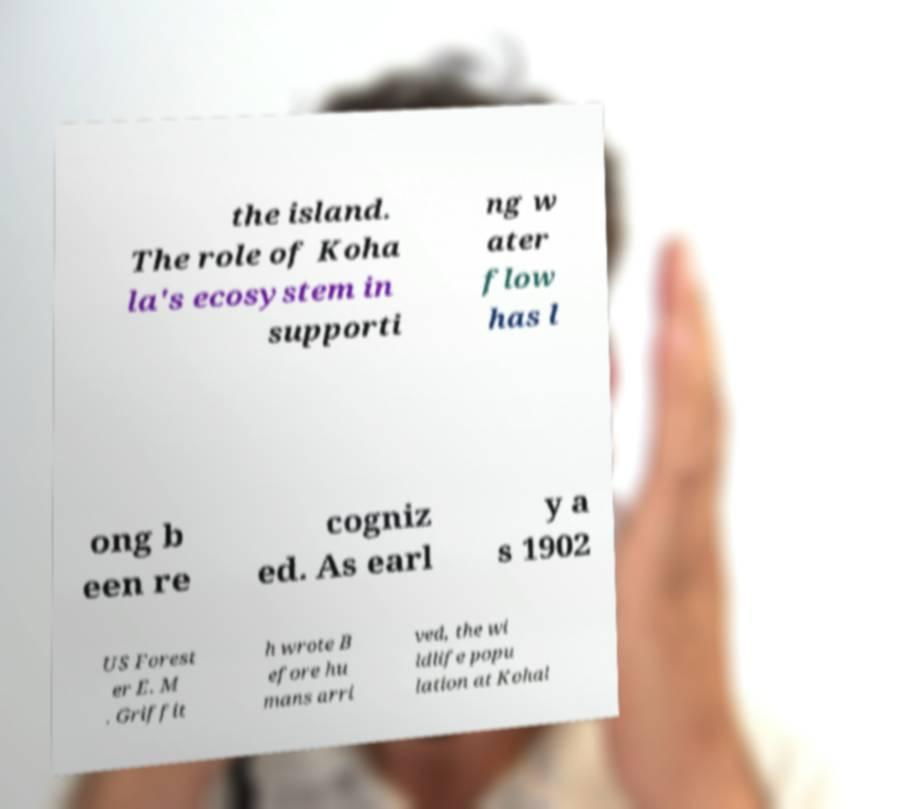Can you accurately transcribe the text from the provided image for me? the island. The role of Koha la's ecosystem in supporti ng w ater flow has l ong b een re cogniz ed. As earl y a s 1902 US Forest er E. M . Griffit h wrote B efore hu mans arri ved, the wi ldlife popu lation at Kohal 